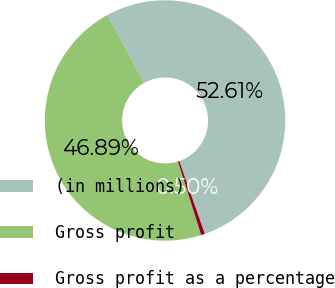<chart> <loc_0><loc_0><loc_500><loc_500><pie_chart><fcel>(in millions)<fcel>Gross profit<fcel>Gross profit as a percentage<nl><fcel>52.62%<fcel>46.89%<fcel>0.5%<nl></chart> 